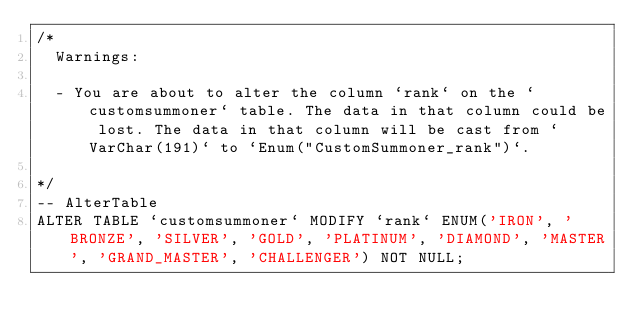Convert code to text. <code><loc_0><loc_0><loc_500><loc_500><_SQL_>/*
  Warnings:

  - You are about to alter the column `rank` on the `customsummoner` table. The data in that column could be lost. The data in that column will be cast from `VarChar(191)` to `Enum("CustomSummoner_rank")`.

*/
-- AlterTable
ALTER TABLE `customsummoner` MODIFY `rank` ENUM('IRON', 'BRONZE', 'SILVER', 'GOLD', 'PLATINUM', 'DIAMOND', 'MASTER', 'GRAND_MASTER', 'CHALLENGER') NOT NULL;
</code> 